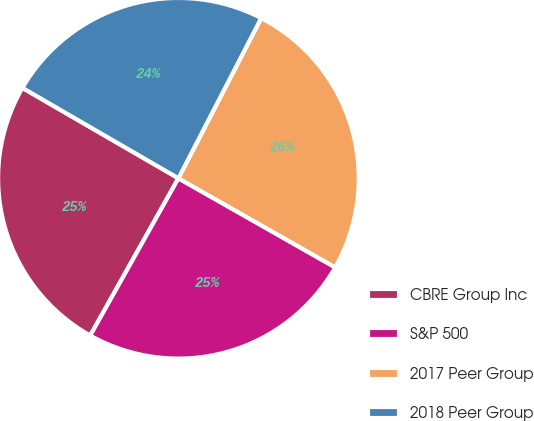Convert chart to OTSL. <chart><loc_0><loc_0><loc_500><loc_500><pie_chart><fcel>CBRE Group Inc<fcel>S&P 500<fcel>2017 Peer Group<fcel>2018 Peer Group<nl><fcel>25.22%<fcel>24.91%<fcel>25.63%<fcel>24.23%<nl></chart> 